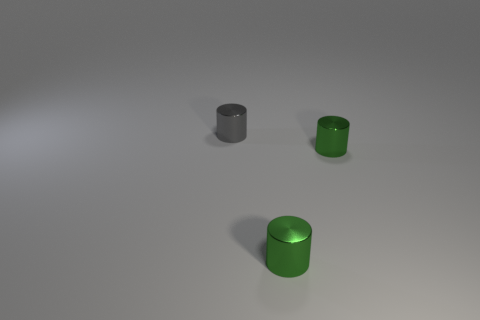How big is the gray metal cylinder?
Provide a succinct answer. Small. Are there any other things that have the same shape as the gray metallic thing?
Provide a short and direct response. Yes. How many tiny green things have the same material as the small gray cylinder?
Offer a terse response. 2. What number of other objects are the same material as the gray thing?
Your response must be concise. 2. Are there fewer big cyan matte blocks than shiny things?
Provide a succinct answer. Yes. What number of large purple spheres are there?
Provide a succinct answer. 0. How many spheres are small gray metal objects or metal things?
Offer a very short reply. 0. There is a gray cylinder; how many objects are in front of it?
Your answer should be compact. 2. How many brown objects are small metal things or large rubber things?
Make the answer very short. 0. Is there a cylinder that has the same size as the gray metallic thing?
Provide a succinct answer. Yes. 